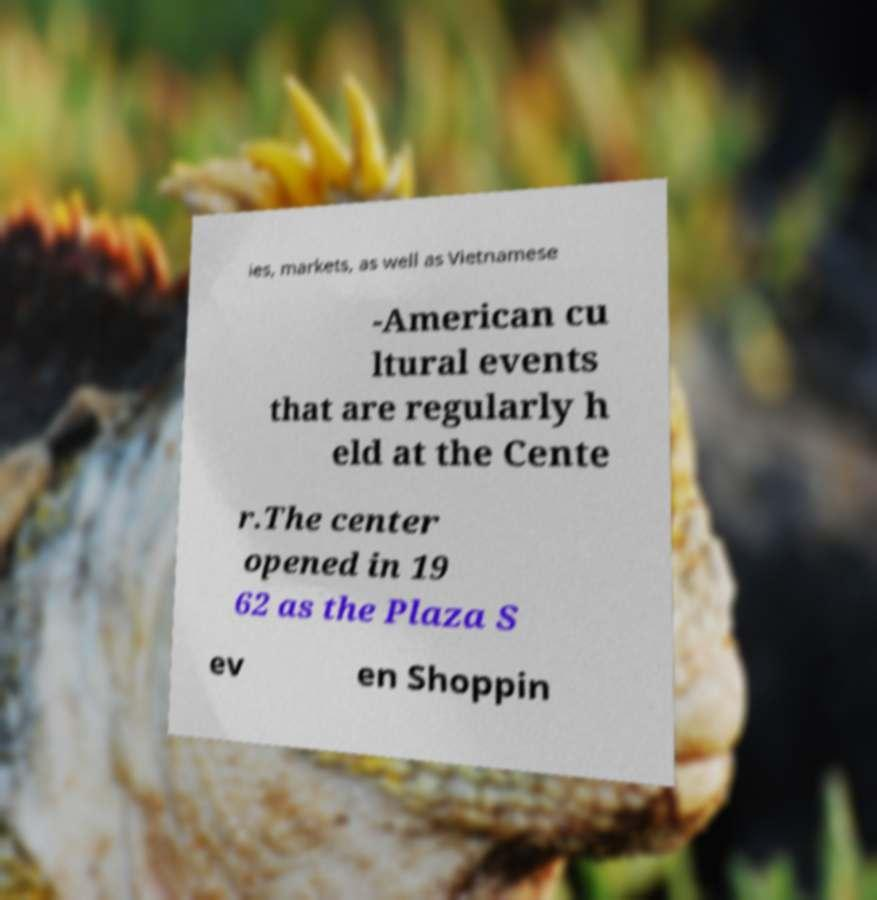Could you assist in decoding the text presented in this image and type it out clearly? ies, markets, as well as Vietnamese -American cu ltural events that are regularly h eld at the Cente r.The center opened in 19 62 as the Plaza S ev en Shoppin 